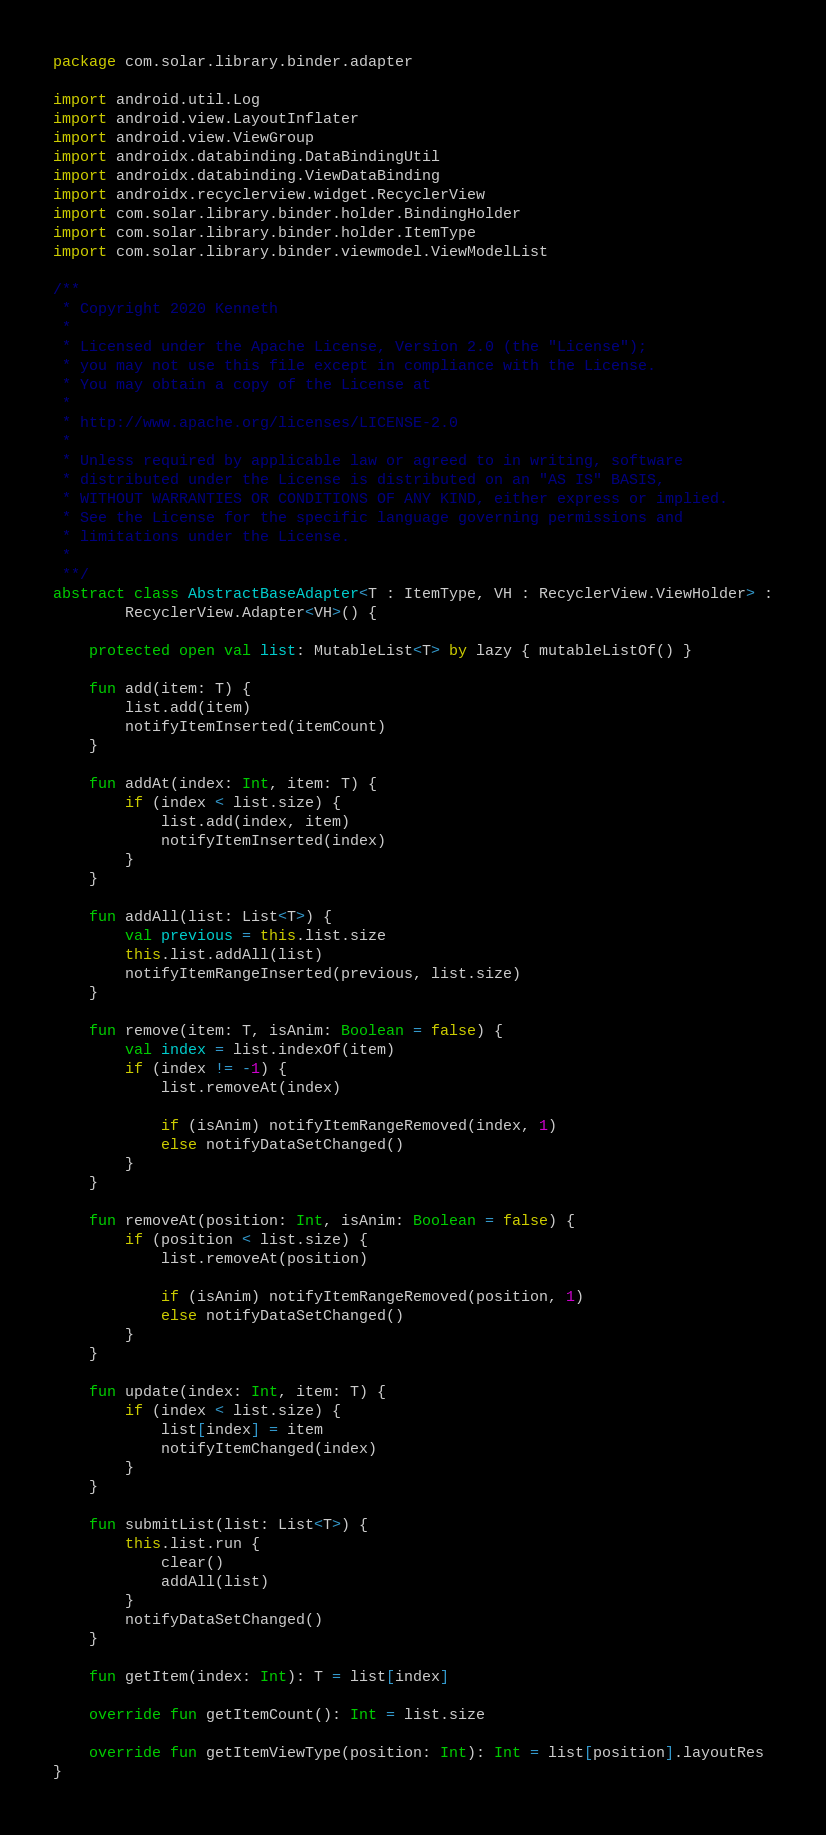Convert code to text. <code><loc_0><loc_0><loc_500><loc_500><_Kotlin_>package com.solar.library.binder.adapter

import android.util.Log
import android.view.LayoutInflater
import android.view.ViewGroup
import androidx.databinding.DataBindingUtil
import androidx.databinding.ViewDataBinding
import androidx.recyclerview.widget.RecyclerView
import com.solar.library.binder.holder.BindingHolder
import com.solar.library.binder.holder.ItemType
import com.solar.library.binder.viewmodel.ViewModelList

/**
 * Copyright 2020 Kenneth
 *
 * Licensed under the Apache License, Version 2.0 (the "License");
 * you may not use this file except in compliance with the License.
 * You may obtain a copy of the License at
 *
 * http://www.apache.org/licenses/LICENSE-2.0
 *
 * Unless required by applicable law or agreed to in writing, software
 * distributed under the License is distributed on an "AS IS" BASIS,
 * WITHOUT WARRANTIES OR CONDITIONS OF ANY KIND, either express or implied.
 * See the License for the specific language governing permissions and
 * limitations under the License.
 *
 **/
abstract class AbstractBaseAdapter<T : ItemType, VH : RecyclerView.ViewHolder> :
        RecyclerView.Adapter<VH>() {

    protected open val list: MutableList<T> by lazy { mutableListOf() }

    fun add(item: T) {
        list.add(item)
        notifyItemInserted(itemCount)
    }

    fun addAt(index: Int, item: T) {
        if (index < list.size) {
            list.add(index, item)
            notifyItemInserted(index)
        }
    }

    fun addAll(list: List<T>) {
        val previous = this.list.size
        this.list.addAll(list)
        notifyItemRangeInserted(previous, list.size)
    }

    fun remove(item: T, isAnim: Boolean = false) {
        val index = list.indexOf(item)
        if (index != -1) {
            list.removeAt(index)

            if (isAnim) notifyItemRangeRemoved(index, 1)
            else notifyDataSetChanged()
        }
    }

    fun removeAt(position: Int, isAnim: Boolean = false) {
        if (position < list.size) {
            list.removeAt(position)

            if (isAnim) notifyItemRangeRemoved(position, 1)
            else notifyDataSetChanged()
        }
    }

    fun update(index: Int, item: T) {
        if (index < list.size) {
            list[index] = item
            notifyItemChanged(index)
        }
    }

    fun submitList(list: List<T>) {
        this.list.run {
            clear()
            addAll(list)
        }
        notifyDataSetChanged()
    }

    fun getItem(index: Int): T = list[index]

    override fun getItemCount(): Int = list.size

    override fun getItemViewType(position: Int): Int = list[position].layoutRes
}</code> 